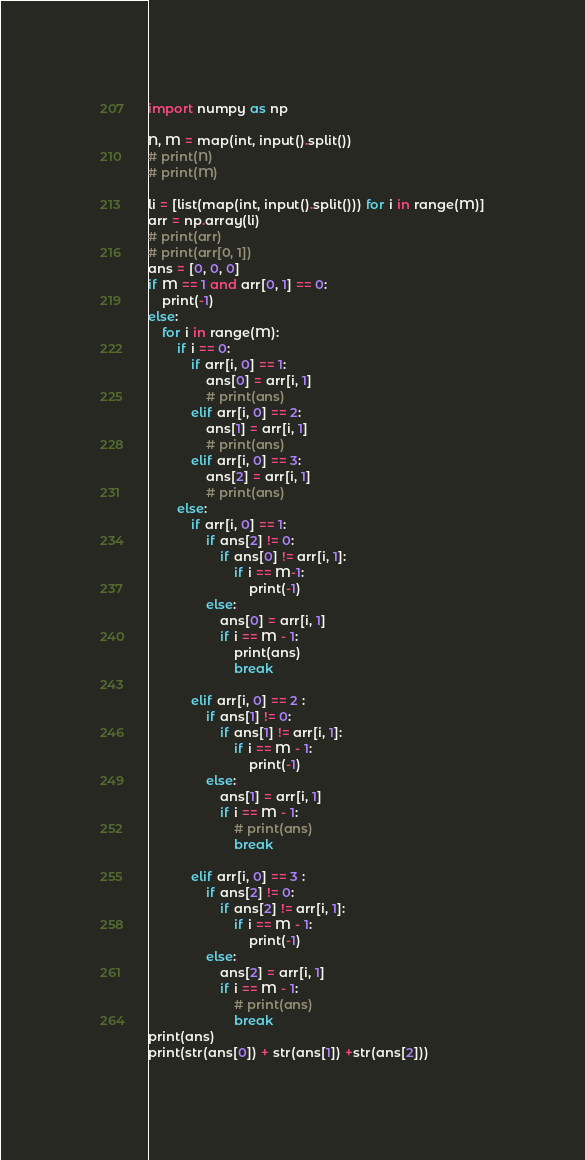Convert code to text. <code><loc_0><loc_0><loc_500><loc_500><_Python_>import numpy as np

N, M = map(int, input().split())
# print(N)
# print(M)

li = [list(map(int, input().split())) for i in range(M)]
arr = np.array(li)
# print(arr)
# print(arr[0, 1])
ans = [0, 0, 0]
if M == 1 and arr[0, 1] == 0:
    print(-1)
else:
    for i in range(M):
        if i == 0:
            if arr[i, 0] == 1:
                ans[0] = arr[i, 1]
                # print(ans)
            elif arr[i, 0] == 2:
                ans[1] = arr[i, 1]
                # print(ans)
            elif arr[i, 0] == 3:
                ans[2] = arr[i, 1]
                # print(ans)
        else:
            if arr[i, 0] == 1:
                if ans[2] != 0:
                    if ans[0] != arr[i, 1]:
                        if i == M-1:
                            print(-1)
                else:
                    ans[0] = arr[i, 1]
                    if i == M - 1:
                        print(ans)
                        break

            elif arr[i, 0] == 2 :
                if ans[1] != 0:
                    if ans[1] != arr[i, 1]:
                        if i == M - 1:
                            print(-1)
                else:
                    ans[1] = arr[i, 1]
                    if i == M - 1:
                        # print(ans)
                        break

            elif arr[i, 0] == 3 :
                if ans[2] != 0:
                    if ans[2] != arr[i, 1]:
                        if i == M - 1:
                            print(-1)
                else:
                    ans[2] = arr[i, 1]
                    if i == M - 1:
                        # print(ans)
                        break
print(ans)
print(str(ans[0]) + str(ans[1]) +str(ans[2]))
</code> 